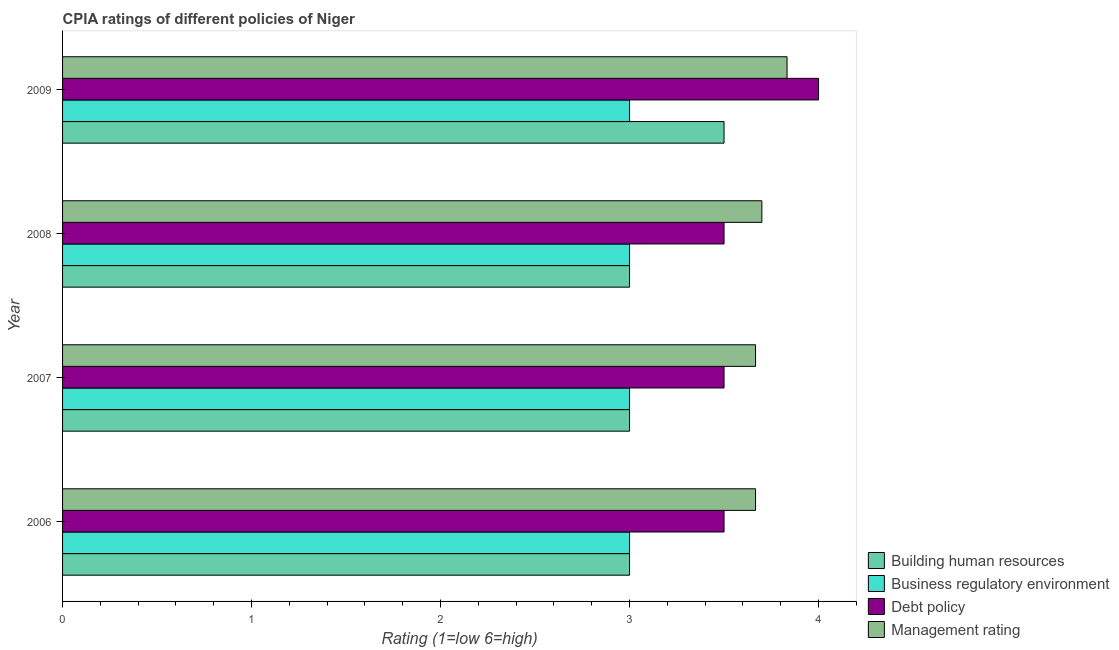Are the number of bars on each tick of the Y-axis equal?
Your answer should be compact. Yes. What is the label of the 4th group of bars from the top?
Keep it short and to the point. 2006. Across all years, what is the maximum cpia rating of debt policy?
Keep it short and to the point. 4. Across all years, what is the minimum cpia rating of building human resources?
Give a very brief answer. 3. What is the total cpia rating of business regulatory environment in the graph?
Your answer should be compact. 12. What is the difference between the cpia rating of management in 2009 and the cpia rating of business regulatory environment in 2008?
Offer a very short reply. 0.83. What is the average cpia rating of building human resources per year?
Offer a terse response. 3.12. In the year 2008, what is the difference between the cpia rating of building human resources and cpia rating of management?
Your response must be concise. -0.7. In how many years, is the cpia rating of debt policy greater than 3 ?
Your answer should be compact. 4. Is the cpia rating of business regulatory environment in 2007 less than that in 2008?
Make the answer very short. No. In how many years, is the cpia rating of debt policy greater than the average cpia rating of debt policy taken over all years?
Give a very brief answer. 1. Is it the case that in every year, the sum of the cpia rating of management and cpia rating of business regulatory environment is greater than the sum of cpia rating of debt policy and cpia rating of building human resources?
Keep it short and to the point. Yes. What does the 3rd bar from the top in 2008 represents?
Your answer should be compact. Business regulatory environment. What does the 4th bar from the bottom in 2007 represents?
Give a very brief answer. Management rating. Are all the bars in the graph horizontal?
Your answer should be compact. Yes. How many years are there in the graph?
Make the answer very short. 4. Where does the legend appear in the graph?
Provide a short and direct response. Bottom right. How many legend labels are there?
Provide a short and direct response. 4. What is the title of the graph?
Offer a terse response. CPIA ratings of different policies of Niger. Does "Social Protection" appear as one of the legend labels in the graph?
Provide a succinct answer. No. What is the label or title of the X-axis?
Make the answer very short. Rating (1=low 6=high). What is the Rating (1=low 6=high) of Business regulatory environment in 2006?
Offer a very short reply. 3. What is the Rating (1=low 6=high) in Management rating in 2006?
Offer a terse response. 3.67. What is the Rating (1=low 6=high) of Business regulatory environment in 2007?
Your answer should be very brief. 3. What is the Rating (1=low 6=high) of Debt policy in 2007?
Your response must be concise. 3.5. What is the Rating (1=low 6=high) of Management rating in 2007?
Your answer should be compact. 3.67. What is the Rating (1=low 6=high) in Business regulatory environment in 2008?
Provide a short and direct response. 3. What is the Rating (1=low 6=high) in Management rating in 2008?
Your answer should be compact. 3.7. What is the Rating (1=low 6=high) in Management rating in 2009?
Provide a short and direct response. 3.83. Across all years, what is the maximum Rating (1=low 6=high) in Management rating?
Your response must be concise. 3.83. Across all years, what is the minimum Rating (1=low 6=high) in Building human resources?
Make the answer very short. 3. Across all years, what is the minimum Rating (1=low 6=high) in Debt policy?
Make the answer very short. 3.5. Across all years, what is the minimum Rating (1=low 6=high) of Management rating?
Your answer should be very brief. 3.67. What is the total Rating (1=low 6=high) in Business regulatory environment in the graph?
Your answer should be very brief. 12. What is the total Rating (1=low 6=high) of Debt policy in the graph?
Offer a terse response. 14.5. What is the total Rating (1=low 6=high) of Management rating in the graph?
Make the answer very short. 14.87. What is the difference between the Rating (1=low 6=high) in Management rating in 2006 and that in 2007?
Provide a succinct answer. 0. What is the difference between the Rating (1=low 6=high) of Building human resources in 2006 and that in 2008?
Provide a succinct answer. 0. What is the difference between the Rating (1=low 6=high) of Management rating in 2006 and that in 2008?
Offer a very short reply. -0.03. What is the difference between the Rating (1=low 6=high) of Building human resources in 2006 and that in 2009?
Make the answer very short. -0.5. What is the difference between the Rating (1=low 6=high) of Management rating in 2006 and that in 2009?
Keep it short and to the point. -0.17. What is the difference between the Rating (1=low 6=high) in Building human resources in 2007 and that in 2008?
Ensure brevity in your answer.  0. What is the difference between the Rating (1=low 6=high) in Business regulatory environment in 2007 and that in 2008?
Your response must be concise. 0. What is the difference between the Rating (1=low 6=high) of Debt policy in 2007 and that in 2008?
Provide a short and direct response. 0. What is the difference between the Rating (1=low 6=high) of Management rating in 2007 and that in 2008?
Provide a short and direct response. -0.03. What is the difference between the Rating (1=low 6=high) in Building human resources in 2007 and that in 2009?
Your answer should be very brief. -0.5. What is the difference between the Rating (1=low 6=high) of Building human resources in 2008 and that in 2009?
Keep it short and to the point. -0.5. What is the difference between the Rating (1=low 6=high) in Debt policy in 2008 and that in 2009?
Offer a terse response. -0.5. What is the difference between the Rating (1=low 6=high) in Management rating in 2008 and that in 2009?
Offer a very short reply. -0.13. What is the difference between the Rating (1=low 6=high) of Building human resources in 2006 and the Rating (1=low 6=high) of Business regulatory environment in 2007?
Provide a succinct answer. 0. What is the difference between the Rating (1=low 6=high) of Building human resources in 2006 and the Rating (1=low 6=high) of Debt policy in 2007?
Ensure brevity in your answer.  -0.5. What is the difference between the Rating (1=low 6=high) in Business regulatory environment in 2006 and the Rating (1=low 6=high) in Debt policy in 2007?
Make the answer very short. -0.5. What is the difference between the Rating (1=low 6=high) of Business regulatory environment in 2006 and the Rating (1=low 6=high) of Management rating in 2007?
Keep it short and to the point. -0.67. What is the difference between the Rating (1=low 6=high) of Building human resources in 2006 and the Rating (1=low 6=high) of Business regulatory environment in 2009?
Your response must be concise. 0. What is the difference between the Rating (1=low 6=high) of Business regulatory environment in 2006 and the Rating (1=low 6=high) of Management rating in 2009?
Provide a succinct answer. -0.83. What is the difference between the Rating (1=low 6=high) of Building human resources in 2007 and the Rating (1=low 6=high) of Business regulatory environment in 2008?
Offer a terse response. 0. What is the difference between the Rating (1=low 6=high) of Building human resources in 2007 and the Rating (1=low 6=high) of Debt policy in 2008?
Make the answer very short. -0.5. What is the difference between the Rating (1=low 6=high) in Building human resources in 2007 and the Rating (1=low 6=high) in Management rating in 2008?
Keep it short and to the point. -0.7. What is the difference between the Rating (1=low 6=high) in Business regulatory environment in 2007 and the Rating (1=low 6=high) in Management rating in 2008?
Your response must be concise. -0.7. What is the difference between the Rating (1=low 6=high) of Debt policy in 2007 and the Rating (1=low 6=high) of Management rating in 2008?
Offer a terse response. -0.2. What is the difference between the Rating (1=low 6=high) in Building human resources in 2007 and the Rating (1=low 6=high) in Business regulatory environment in 2009?
Make the answer very short. 0. What is the difference between the Rating (1=low 6=high) in Building human resources in 2007 and the Rating (1=low 6=high) in Debt policy in 2009?
Offer a very short reply. -1. What is the difference between the Rating (1=low 6=high) in Building human resources in 2008 and the Rating (1=low 6=high) in Management rating in 2009?
Offer a very short reply. -0.83. What is the difference between the Rating (1=low 6=high) in Business regulatory environment in 2008 and the Rating (1=low 6=high) in Management rating in 2009?
Your response must be concise. -0.83. What is the difference between the Rating (1=low 6=high) in Debt policy in 2008 and the Rating (1=low 6=high) in Management rating in 2009?
Offer a terse response. -0.33. What is the average Rating (1=low 6=high) of Building human resources per year?
Provide a succinct answer. 3.12. What is the average Rating (1=low 6=high) in Business regulatory environment per year?
Make the answer very short. 3. What is the average Rating (1=low 6=high) in Debt policy per year?
Offer a very short reply. 3.62. What is the average Rating (1=low 6=high) of Management rating per year?
Give a very brief answer. 3.72. In the year 2006, what is the difference between the Rating (1=low 6=high) in Building human resources and Rating (1=low 6=high) in Debt policy?
Offer a terse response. -0.5. In the year 2006, what is the difference between the Rating (1=low 6=high) in Business regulatory environment and Rating (1=low 6=high) in Management rating?
Keep it short and to the point. -0.67. In the year 2006, what is the difference between the Rating (1=low 6=high) in Debt policy and Rating (1=low 6=high) in Management rating?
Give a very brief answer. -0.17. In the year 2007, what is the difference between the Rating (1=low 6=high) of Building human resources and Rating (1=low 6=high) of Debt policy?
Make the answer very short. -0.5. In the year 2007, what is the difference between the Rating (1=low 6=high) of Building human resources and Rating (1=low 6=high) of Management rating?
Your response must be concise. -0.67. In the year 2007, what is the difference between the Rating (1=low 6=high) of Business regulatory environment and Rating (1=low 6=high) of Management rating?
Your answer should be very brief. -0.67. In the year 2007, what is the difference between the Rating (1=low 6=high) in Debt policy and Rating (1=low 6=high) in Management rating?
Your answer should be very brief. -0.17. In the year 2008, what is the difference between the Rating (1=low 6=high) of Debt policy and Rating (1=low 6=high) of Management rating?
Offer a terse response. -0.2. In the year 2009, what is the difference between the Rating (1=low 6=high) of Building human resources and Rating (1=low 6=high) of Business regulatory environment?
Keep it short and to the point. 0.5. In the year 2009, what is the difference between the Rating (1=low 6=high) in Building human resources and Rating (1=low 6=high) in Debt policy?
Give a very brief answer. -0.5. In the year 2009, what is the difference between the Rating (1=low 6=high) of Business regulatory environment and Rating (1=low 6=high) of Management rating?
Ensure brevity in your answer.  -0.83. What is the ratio of the Rating (1=low 6=high) in Building human resources in 2006 to that in 2007?
Offer a very short reply. 1. What is the ratio of the Rating (1=low 6=high) of Business regulatory environment in 2006 to that in 2007?
Provide a short and direct response. 1. What is the ratio of the Rating (1=low 6=high) in Management rating in 2006 to that in 2007?
Your response must be concise. 1. What is the ratio of the Rating (1=low 6=high) in Business regulatory environment in 2006 to that in 2008?
Offer a very short reply. 1. What is the ratio of the Rating (1=low 6=high) of Management rating in 2006 to that in 2008?
Make the answer very short. 0.99. What is the ratio of the Rating (1=low 6=high) in Business regulatory environment in 2006 to that in 2009?
Keep it short and to the point. 1. What is the ratio of the Rating (1=low 6=high) in Management rating in 2006 to that in 2009?
Provide a short and direct response. 0.96. What is the ratio of the Rating (1=low 6=high) of Business regulatory environment in 2007 to that in 2008?
Offer a very short reply. 1. What is the ratio of the Rating (1=low 6=high) of Debt policy in 2007 to that in 2008?
Make the answer very short. 1. What is the ratio of the Rating (1=low 6=high) of Debt policy in 2007 to that in 2009?
Provide a succinct answer. 0.88. What is the ratio of the Rating (1=low 6=high) in Management rating in 2007 to that in 2009?
Keep it short and to the point. 0.96. What is the ratio of the Rating (1=low 6=high) of Business regulatory environment in 2008 to that in 2009?
Make the answer very short. 1. What is the ratio of the Rating (1=low 6=high) of Management rating in 2008 to that in 2009?
Your answer should be compact. 0.97. What is the difference between the highest and the second highest Rating (1=low 6=high) of Debt policy?
Provide a short and direct response. 0.5. What is the difference between the highest and the second highest Rating (1=low 6=high) of Management rating?
Offer a terse response. 0.13. What is the difference between the highest and the lowest Rating (1=low 6=high) of Business regulatory environment?
Keep it short and to the point. 0. What is the difference between the highest and the lowest Rating (1=low 6=high) in Management rating?
Ensure brevity in your answer.  0.17. 